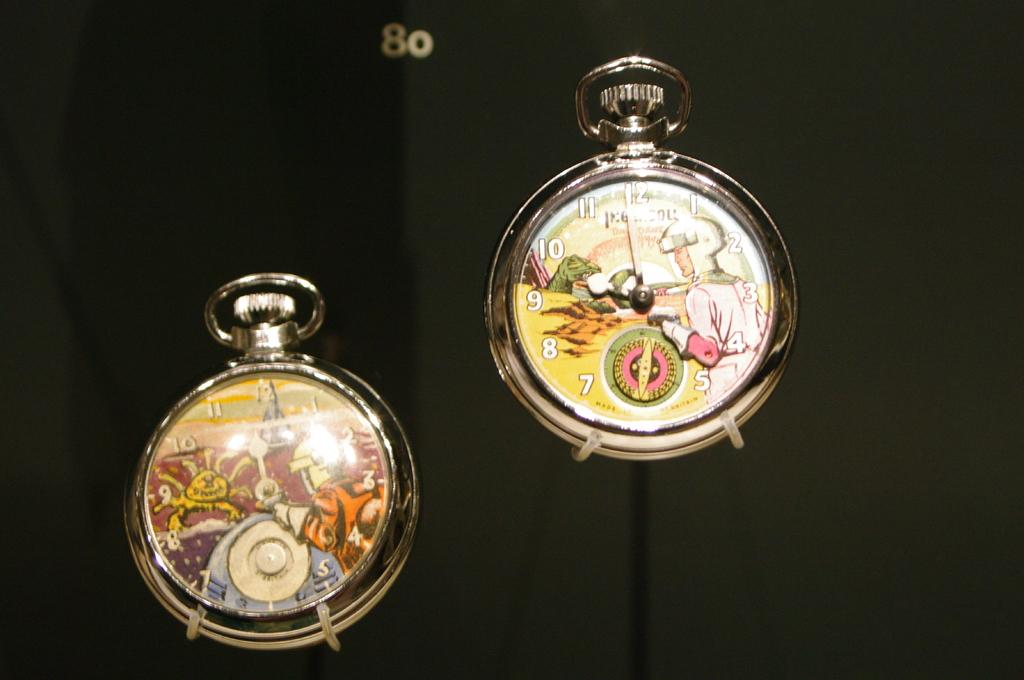What time is shown on the clock on the right?
Ensure brevity in your answer.  9:58. What´s the number behind the  clocks?
Provide a succinct answer. 80. 